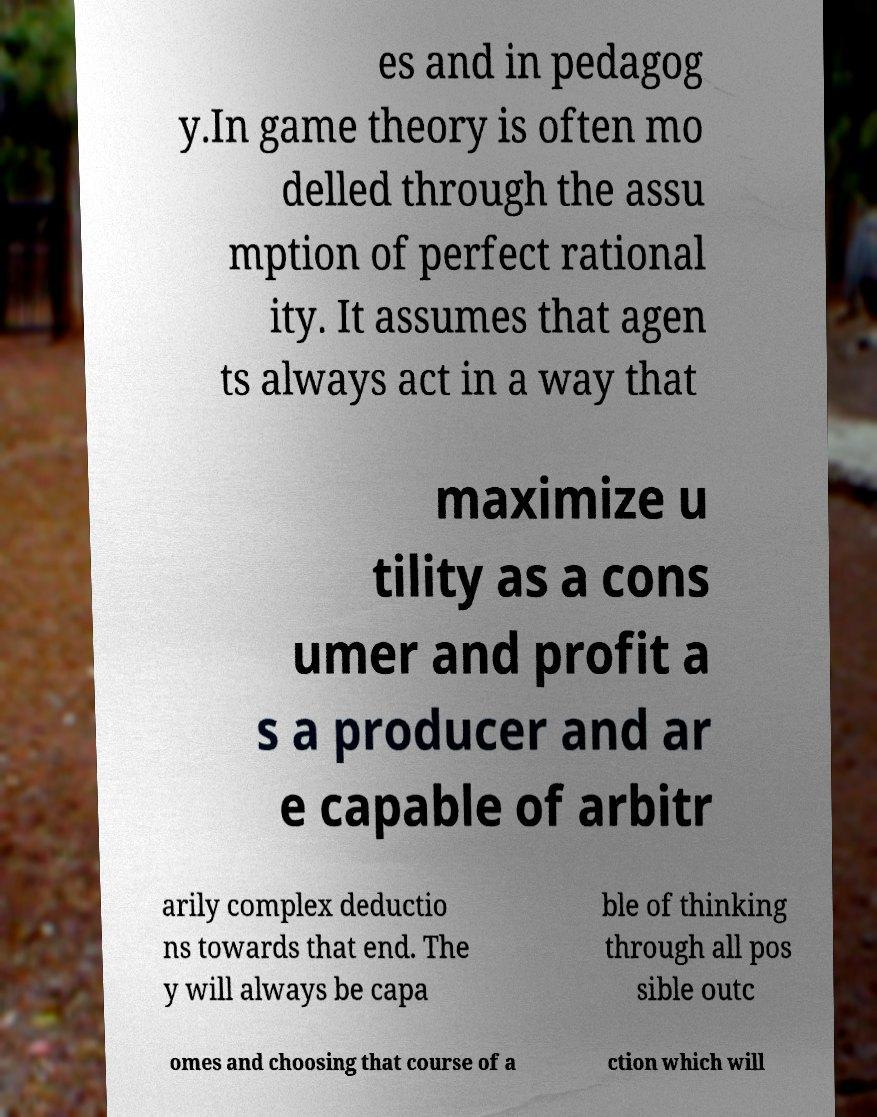For documentation purposes, I need the text within this image transcribed. Could you provide that? es and in pedagog y.In game theory is often mo delled through the assu mption of perfect rational ity. It assumes that agen ts always act in a way that maximize u tility as a cons umer and profit a s a producer and ar e capable of arbitr arily complex deductio ns towards that end. The y will always be capa ble of thinking through all pos sible outc omes and choosing that course of a ction which will 